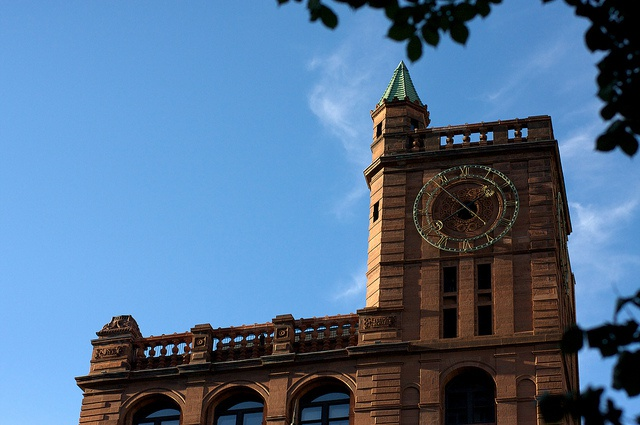Describe the objects in this image and their specific colors. I can see a clock in lightblue, black, maroon, and gray tones in this image. 